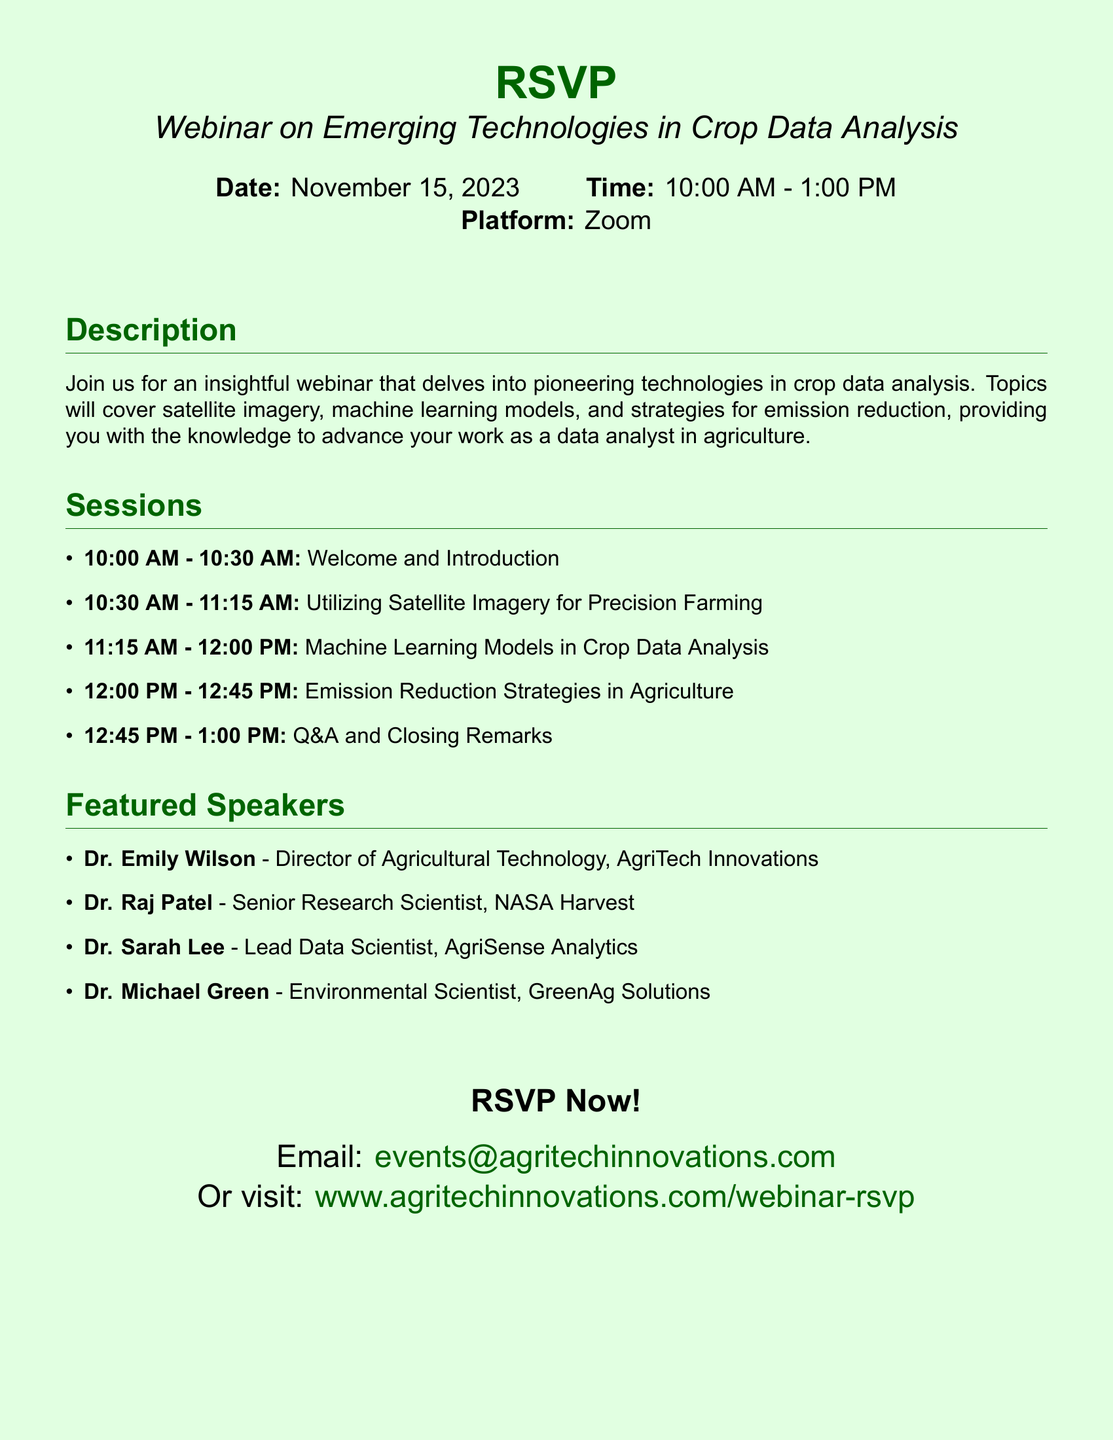What is the date of the webinar? The date of the webinar is explicitly stated in the document header, which is November 15, 2023.
Answer: November 15, 2023 What time does the webinar start? The start time for the webinar is clearly mentioned in the document, which is 10:00 AM.
Answer: 10:00 AM Who is the director of Agricultural Technology? The document lists Dr. Emily Wilson as the Director of Agricultural Technology associated with AgriTech Innovations under the Featured Speakers section.
Answer: Dr. Emily Wilson Which technology will be discussed at 10:30 AM? The session at 10:30 AM is titled "Utilizing Satellite Imagery for Precision Farming," indicating what technology will be discussed.
Answer: Satellite Imagery How long is the Q&A session? The document specifies that the Q&A and closing remarks session at 12:45 PM lasts for a total of 15 minutes.
Answer: 15 minutes Which speaker is from NASA Harvest? The document identifies Dr. Raj Patel as the Senior Research Scientist associated with NASA Harvest under the Featured Speakers section.
Answer: Dr. Raj Patel How many total sessions are included in the webinar? By counting the listed sessions in the Sessions section, there are a total of five sessions being held during the webinar.
Answer: Five What is the platform used for hosting the webinar? The platform hosting the webinar is indicated in the document as Zoom.
Answer: Zoom Where can participants RSVP? The document provides a specific email and a website link for participants to RSVP, clearly stating where they can do so.
Answer: events@agritechinnovations.com 